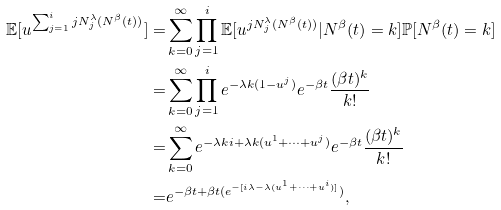Convert formula to latex. <formula><loc_0><loc_0><loc_500><loc_500>\mathbb { E } [ u ^ { \sum _ { j = 1 } ^ { i } j N _ { j } ^ { \lambda } ( N ^ { \beta } ( t ) ) } ] = & \sum _ { k = 0 } ^ { \infty } \prod _ { j = 1 } ^ { i } \mathbb { E } [ u ^ { j N _ { j } ^ { \lambda } ( N ^ { \beta } ( t ) ) } | N ^ { \beta } ( t ) = k ] \mathbb { P } [ N ^ { \beta } ( t ) = k ] \\ = & \sum _ { k = 0 } ^ { \infty } \prod _ { j = 1 } ^ { i } e ^ { - \lambda k ( 1 - u ^ { j } ) } e ^ { - \beta t } \frac { ( \beta t ) ^ { k } } { k ! } \\ = & \sum _ { k = 0 } ^ { \infty } e ^ { - \lambda k i + \lambda k ( u ^ { 1 } + \dots + u ^ { j } ) } e ^ { - \beta t } \frac { ( \beta t ) ^ { k } } { k ! } \\ = & e ^ { - \beta t + \beta t ( e ^ { - [ i \lambda - \lambda ( u ^ { 1 } + \dots + u ^ { i } ) ] } ) } ,</formula> 